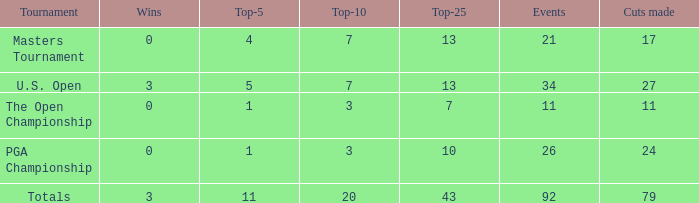Name the total number of wins with top-25 of 10 and events less than 26 0.0. 